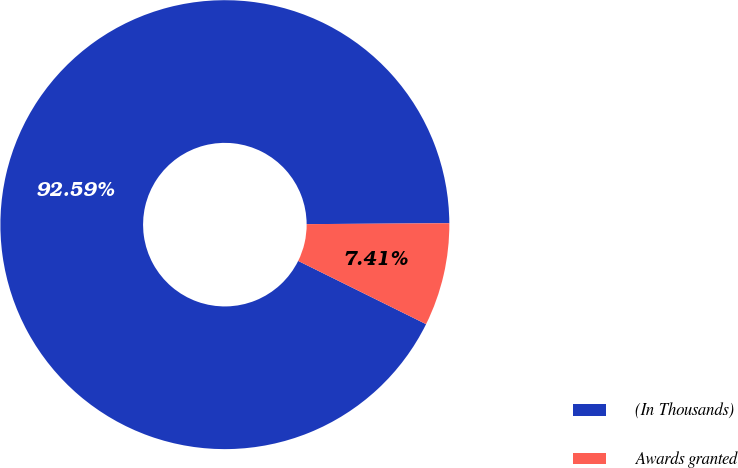Convert chart to OTSL. <chart><loc_0><loc_0><loc_500><loc_500><pie_chart><fcel>(In Thousands)<fcel>Awards granted<nl><fcel>92.59%<fcel>7.41%<nl></chart> 